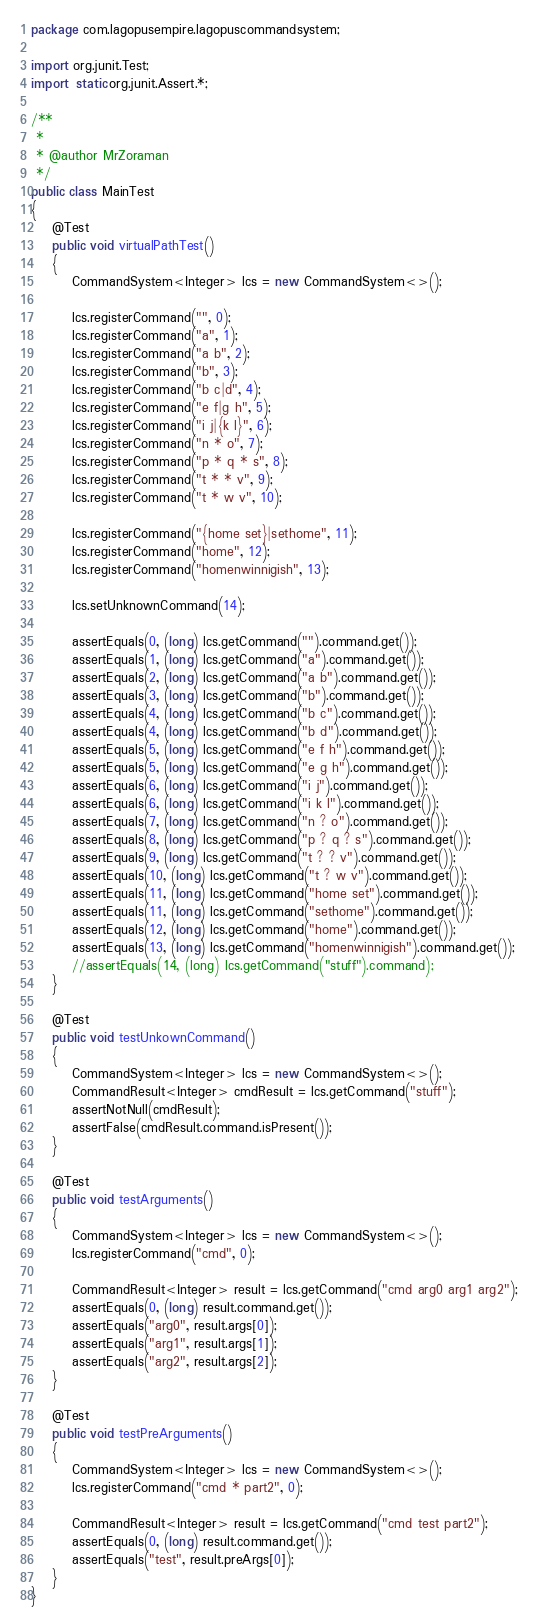<code> <loc_0><loc_0><loc_500><loc_500><_Java_>package com.lagopusempire.lagopuscommandsystem;

import org.junit.Test;
import static org.junit.Assert.*;

/**
 *
 * @author MrZoraman
 */
public class MainTest
{
    @Test
    public void virtualPathTest()
    {
        CommandSystem<Integer> lcs = new CommandSystem<>();
        
        lcs.registerCommand("", 0);
        lcs.registerCommand("a", 1);
        lcs.registerCommand("a b", 2);
        lcs.registerCommand("b", 3);
        lcs.registerCommand("b c|d", 4);
        lcs.registerCommand("e f|g h", 5);
        lcs.registerCommand("i j|{k l}", 6);
        lcs.registerCommand("n * o", 7);
        lcs.registerCommand("p * q * s", 8);
        lcs.registerCommand("t * * v", 9);
        lcs.registerCommand("t * w v", 10);
        
        lcs.registerCommand("{home set}|sethome", 11);
        lcs.registerCommand("home", 12);
        lcs.registerCommand("homenwinnigish", 13);
        
        lcs.setUnknownCommand(14);
        
        assertEquals(0, (long) lcs.getCommand("").command.get());
        assertEquals(1, (long) lcs.getCommand("a").command.get());
        assertEquals(2, (long) lcs.getCommand("a b").command.get());
        assertEquals(3, (long) lcs.getCommand("b").command.get());
        assertEquals(4, (long) lcs.getCommand("b c").command.get());
        assertEquals(4, (long) lcs.getCommand("b d").command.get());
        assertEquals(5, (long) lcs.getCommand("e f h").command.get());
        assertEquals(5, (long) lcs.getCommand("e g h").command.get());
        assertEquals(6, (long) lcs.getCommand("i j").command.get());
        assertEquals(6, (long) lcs.getCommand("i k l").command.get());
        assertEquals(7, (long) lcs.getCommand("n ? o").command.get());
        assertEquals(8, (long) lcs.getCommand("p ? q ? s").command.get());
        assertEquals(9, (long) lcs.getCommand("t ? ? v").command.get());
        assertEquals(10, (long) lcs.getCommand("t ? w v").command.get());
        assertEquals(11, (long) lcs.getCommand("home set").command.get());
        assertEquals(11, (long) lcs.getCommand("sethome").command.get());
        assertEquals(12, (long) lcs.getCommand("home").command.get());
        assertEquals(13, (long) lcs.getCommand("homenwinnigish").command.get());
        //assertEquals(14, (long) lcs.getCommand("stuff").command);
    }
    
    @Test
    public void testUnkownCommand()
    {
        CommandSystem<Integer> lcs = new CommandSystem<>();
        CommandResult<Integer> cmdResult = lcs.getCommand("stuff");
        assertNotNull(cmdResult);
        assertFalse(cmdResult.command.isPresent());
    }
    
    @Test
    public void testArguments()
    {
        CommandSystem<Integer> lcs = new CommandSystem<>();
        lcs.registerCommand("cmd", 0);
        
        CommandResult<Integer> result = lcs.getCommand("cmd arg0 arg1 arg2");
        assertEquals(0, (long) result.command.get());
        assertEquals("arg0", result.args[0]);
        assertEquals("arg1", result.args[1]);
        assertEquals("arg2", result.args[2]);
    }
    
    @Test
    public void testPreArguments()
    {
        CommandSystem<Integer> lcs = new CommandSystem<>();
        lcs.registerCommand("cmd * part2", 0);
        
        CommandResult<Integer> result = lcs.getCommand("cmd test part2");
        assertEquals(0, (long) result.command.get());
        assertEquals("test", result.preArgs[0]);
    }
}
</code> 